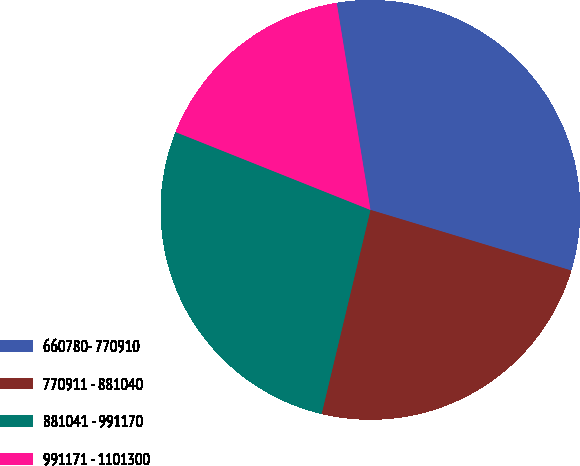Convert chart. <chart><loc_0><loc_0><loc_500><loc_500><pie_chart><fcel>660780- 770910<fcel>770911 - 881040<fcel>881041 - 991170<fcel>991171 - 1101300<nl><fcel>32.24%<fcel>24.07%<fcel>27.31%<fcel>16.37%<nl></chart> 